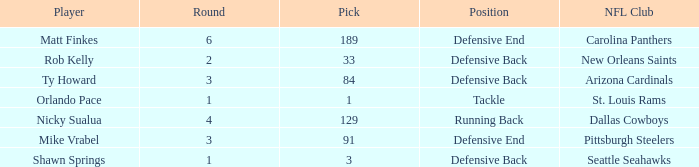What is the lowest pick that has arizona cardinals as the NFL club? 84.0. 